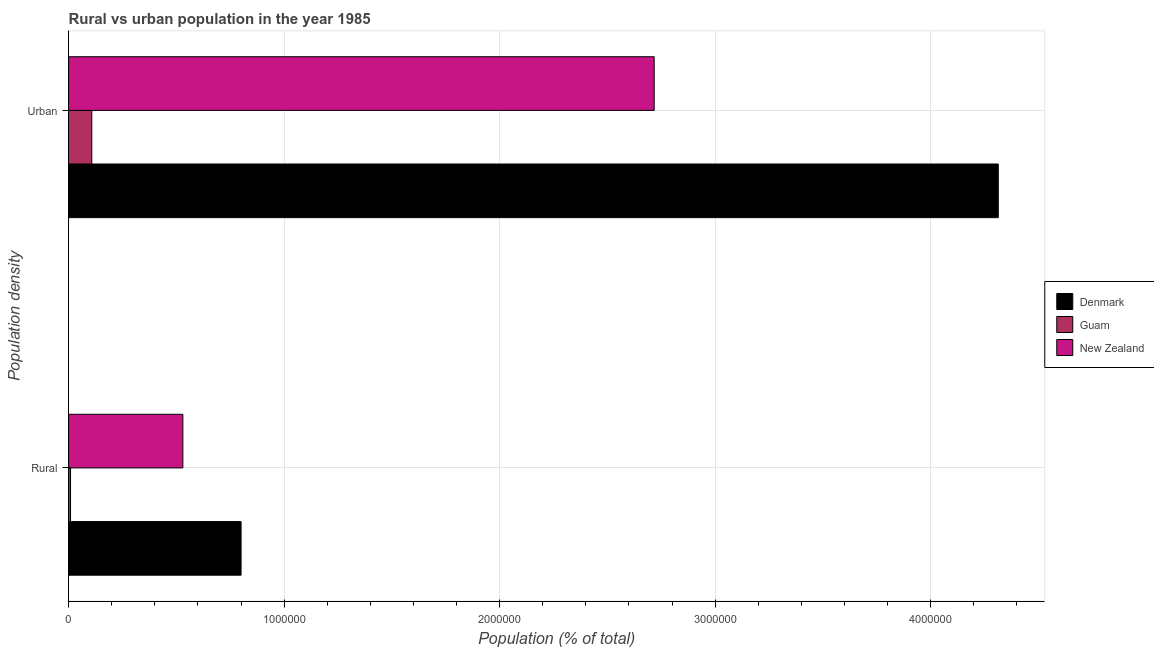How many groups of bars are there?
Ensure brevity in your answer.  2. Are the number of bars on each tick of the Y-axis equal?
Your response must be concise. Yes. How many bars are there on the 2nd tick from the bottom?
Provide a short and direct response. 3. What is the label of the 2nd group of bars from the top?
Provide a succinct answer. Rural. What is the urban population density in Denmark?
Ensure brevity in your answer.  4.31e+06. Across all countries, what is the maximum urban population density?
Your answer should be compact. 4.31e+06. Across all countries, what is the minimum rural population density?
Give a very brief answer. 8931. In which country was the urban population density minimum?
Your answer should be compact. Guam. What is the total rural population density in the graph?
Ensure brevity in your answer.  1.34e+06. What is the difference between the rural population density in New Zealand and that in Denmark?
Your response must be concise. -2.70e+05. What is the difference between the rural population density in New Zealand and the urban population density in Denmark?
Make the answer very short. -3.78e+06. What is the average rural population density per country?
Ensure brevity in your answer.  4.46e+05. What is the difference between the rural population density and urban population density in Denmark?
Your answer should be compact. -3.51e+06. In how many countries, is the urban population density greater than 1200000 %?
Offer a terse response. 2. What is the ratio of the urban population density in Guam to that in New Zealand?
Make the answer very short. 0.04. In how many countries, is the urban population density greater than the average urban population density taken over all countries?
Your answer should be compact. 2. What does the 3rd bar from the top in Urban represents?
Ensure brevity in your answer.  Denmark. What does the 2nd bar from the bottom in Rural represents?
Keep it short and to the point. Guam. Are the values on the major ticks of X-axis written in scientific E-notation?
Provide a succinct answer. No. Does the graph contain grids?
Your response must be concise. Yes. How many legend labels are there?
Your response must be concise. 3. What is the title of the graph?
Your answer should be very brief. Rural vs urban population in the year 1985. What is the label or title of the X-axis?
Give a very brief answer. Population (% of total). What is the label or title of the Y-axis?
Provide a short and direct response. Population density. What is the Population (% of total) of Denmark in Rural?
Offer a very short reply. 8.00e+05. What is the Population (% of total) in Guam in Rural?
Provide a succinct answer. 8931. What is the Population (% of total) of New Zealand in Rural?
Your answer should be compact. 5.30e+05. What is the Population (% of total) of Denmark in Urban?
Keep it short and to the point. 4.31e+06. What is the Population (% of total) of Guam in Urban?
Offer a very short reply. 1.08e+05. What is the Population (% of total) in New Zealand in Urban?
Make the answer very short. 2.72e+06. Across all Population density, what is the maximum Population (% of total) in Denmark?
Provide a short and direct response. 4.31e+06. Across all Population density, what is the maximum Population (% of total) in Guam?
Your response must be concise. 1.08e+05. Across all Population density, what is the maximum Population (% of total) in New Zealand?
Offer a terse response. 2.72e+06. Across all Population density, what is the minimum Population (% of total) of Denmark?
Your answer should be compact. 8.00e+05. Across all Population density, what is the minimum Population (% of total) of Guam?
Your answer should be very brief. 8931. Across all Population density, what is the minimum Population (% of total) in New Zealand?
Ensure brevity in your answer.  5.30e+05. What is the total Population (% of total) in Denmark in the graph?
Your answer should be very brief. 5.11e+06. What is the total Population (% of total) in Guam in the graph?
Ensure brevity in your answer.  1.17e+05. What is the total Population (% of total) of New Zealand in the graph?
Your response must be concise. 3.25e+06. What is the difference between the Population (% of total) in Denmark in Rural and that in Urban?
Ensure brevity in your answer.  -3.51e+06. What is the difference between the Population (% of total) in Guam in Rural and that in Urban?
Offer a very short reply. -9.87e+04. What is the difference between the Population (% of total) in New Zealand in Rural and that in Urban?
Your answer should be compact. -2.19e+06. What is the difference between the Population (% of total) of Denmark in Rural and the Population (% of total) of Guam in Urban?
Ensure brevity in your answer.  6.93e+05. What is the difference between the Population (% of total) of Denmark in Rural and the Population (% of total) of New Zealand in Urban?
Ensure brevity in your answer.  -1.92e+06. What is the difference between the Population (% of total) in Guam in Rural and the Population (% of total) in New Zealand in Urban?
Your answer should be compact. -2.71e+06. What is the average Population (% of total) in Denmark per Population density?
Your answer should be compact. 2.56e+06. What is the average Population (% of total) in Guam per Population density?
Offer a very short reply. 5.83e+04. What is the average Population (% of total) of New Zealand per Population density?
Provide a succinct answer. 1.62e+06. What is the difference between the Population (% of total) of Denmark and Population (% of total) of Guam in Rural?
Offer a terse response. 7.91e+05. What is the difference between the Population (% of total) in Denmark and Population (% of total) in New Zealand in Rural?
Ensure brevity in your answer.  2.70e+05. What is the difference between the Population (% of total) in Guam and Population (% of total) in New Zealand in Rural?
Your answer should be very brief. -5.21e+05. What is the difference between the Population (% of total) of Denmark and Population (% of total) of Guam in Urban?
Your answer should be very brief. 4.21e+06. What is the difference between the Population (% of total) in Denmark and Population (% of total) in New Zealand in Urban?
Give a very brief answer. 1.60e+06. What is the difference between the Population (% of total) in Guam and Population (% of total) in New Zealand in Urban?
Provide a short and direct response. -2.61e+06. What is the ratio of the Population (% of total) in Denmark in Rural to that in Urban?
Provide a short and direct response. 0.19. What is the ratio of the Population (% of total) of Guam in Rural to that in Urban?
Keep it short and to the point. 0.08. What is the ratio of the Population (% of total) in New Zealand in Rural to that in Urban?
Your response must be concise. 0.2. What is the difference between the highest and the second highest Population (% of total) in Denmark?
Ensure brevity in your answer.  3.51e+06. What is the difference between the highest and the second highest Population (% of total) of Guam?
Offer a terse response. 9.87e+04. What is the difference between the highest and the second highest Population (% of total) in New Zealand?
Give a very brief answer. 2.19e+06. What is the difference between the highest and the lowest Population (% of total) in Denmark?
Offer a very short reply. 3.51e+06. What is the difference between the highest and the lowest Population (% of total) in Guam?
Offer a terse response. 9.87e+04. What is the difference between the highest and the lowest Population (% of total) of New Zealand?
Your response must be concise. 2.19e+06. 